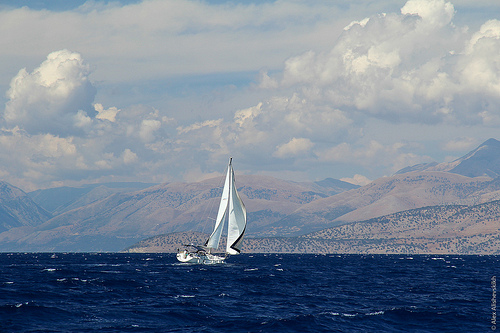How many boats? 1 